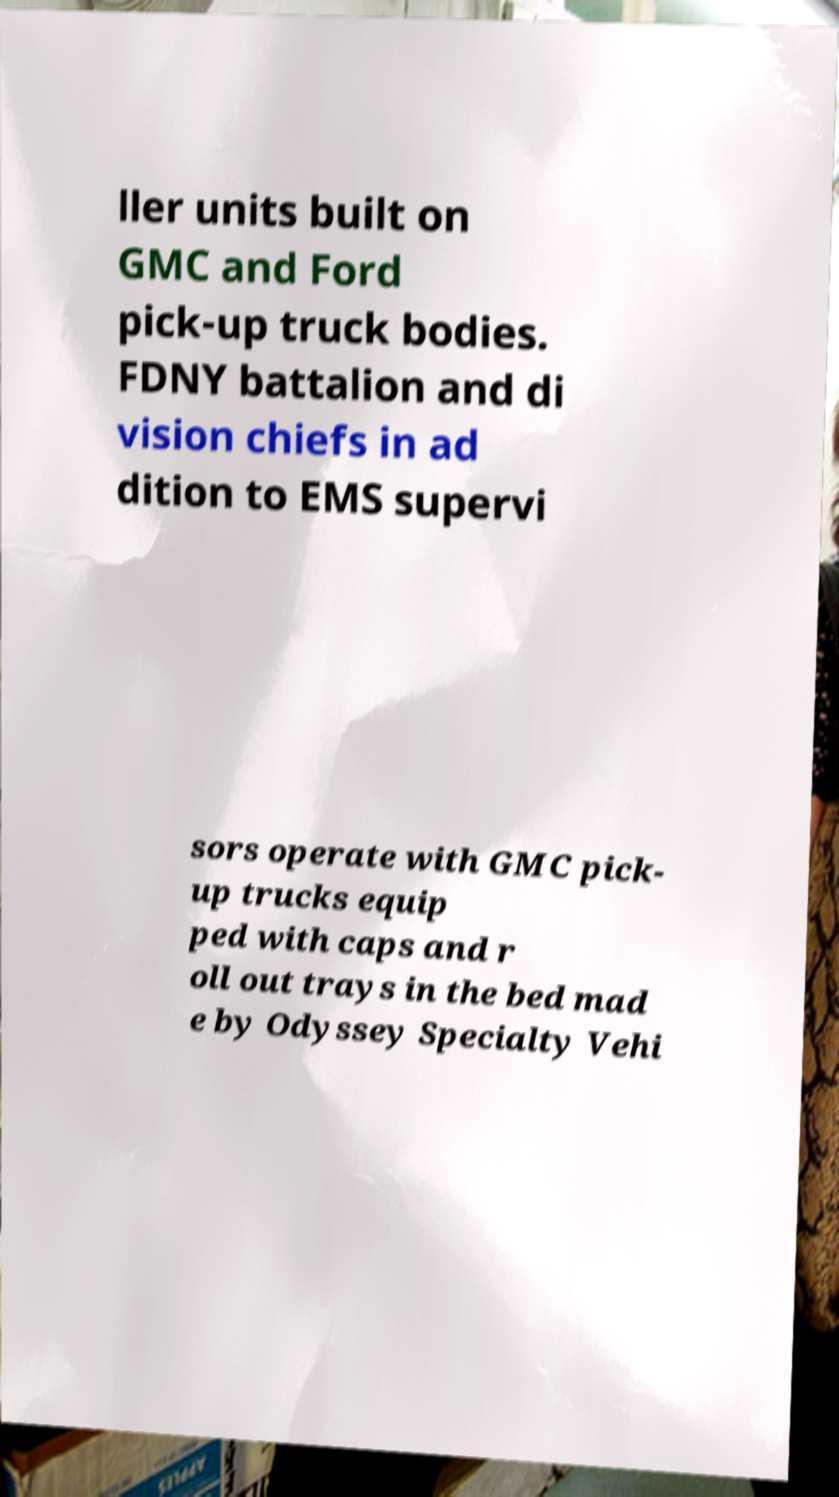Could you extract and type out the text from this image? ller units built on GMC and Ford pick-up truck bodies. FDNY battalion and di vision chiefs in ad dition to EMS supervi sors operate with GMC pick- up trucks equip ped with caps and r oll out trays in the bed mad e by Odyssey Specialty Vehi 